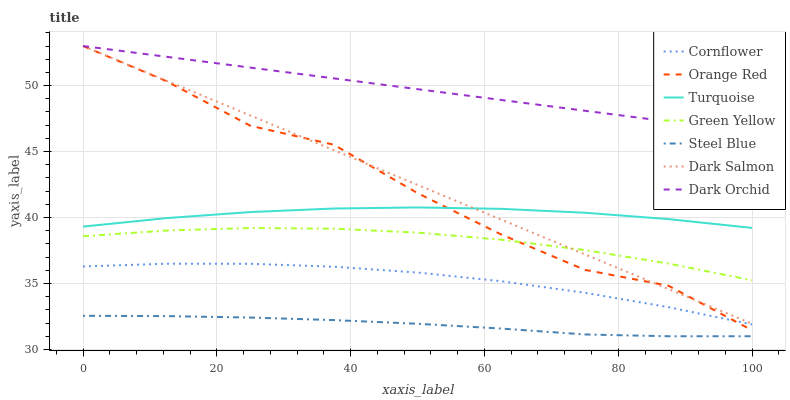Does Steel Blue have the minimum area under the curve?
Answer yes or no. Yes. Does Dark Orchid have the maximum area under the curve?
Answer yes or no. Yes. Does Turquoise have the minimum area under the curve?
Answer yes or no. No. Does Turquoise have the maximum area under the curve?
Answer yes or no. No. Is Dark Orchid the smoothest?
Answer yes or no. Yes. Is Orange Red the roughest?
Answer yes or no. Yes. Is Turquoise the smoothest?
Answer yes or no. No. Is Turquoise the roughest?
Answer yes or no. No. Does Steel Blue have the lowest value?
Answer yes or no. Yes. Does Turquoise have the lowest value?
Answer yes or no. No. Does Orange Red have the highest value?
Answer yes or no. Yes. Does Turquoise have the highest value?
Answer yes or no. No. Is Steel Blue less than Dark Salmon?
Answer yes or no. Yes. Is Dark Orchid greater than Steel Blue?
Answer yes or no. Yes. Does Orange Red intersect Cornflower?
Answer yes or no. Yes. Is Orange Red less than Cornflower?
Answer yes or no. No. Is Orange Red greater than Cornflower?
Answer yes or no. No. Does Steel Blue intersect Dark Salmon?
Answer yes or no. No. 